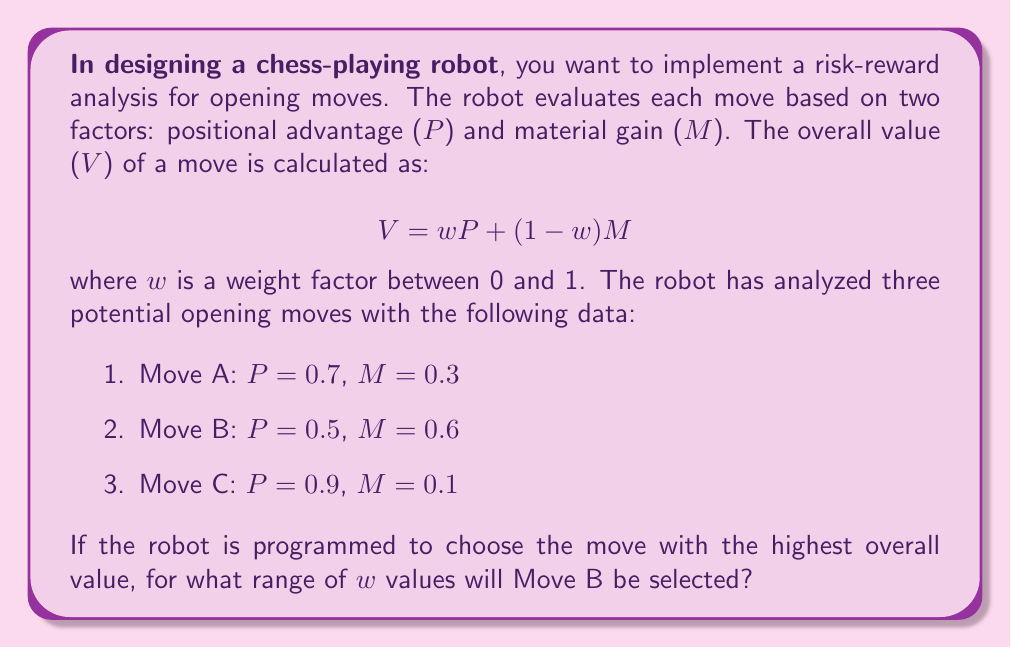Can you solve this math problem? To solve this problem, we need to follow these steps:

1. Express the value function for each move in terms of $w$.
2. Determine the conditions for Move B to have a higher value than both Move A and Move C.
3. Solve the resulting inequalities to find the range of $w$.

Step 1: Express value functions

For Move A: $V_A = 0.7w + 0.3(1-w) = 0.7w + 0.3 - 0.3w = 0.4w + 0.3$
For Move B: $V_B = 0.5w + 0.6(1-w) = 0.5w + 0.6 - 0.6w = -0.1w + 0.6$
For Move C: $V_C = 0.9w + 0.1(1-w) = 0.9w + 0.1 - 0.1w = 0.8w + 0.1$

Step 2: Determine conditions for Move B to be selected

For Move B to be selected, it must have a higher value than both Move A and Move C:

$V_B > V_A$ and $V_B > V_C$

$-0.1w + 0.6 > 0.4w + 0.3$ and $-0.1w + 0.6 > 0.8w + 0.1$

Step 3: Solve the inequalities

For $V_B > V_A$:
$-0.1w + 0.6 > 0.4w + 0.3$
$0.3 > 0.5w$
$w < 0.6$

For $V_B > V_C$:
$-0.1w + 0.6 > 0.8w + 0.1$
$0.5 > 0.9w$
$w < \frac{5}{9} \approx 0.556$

For Move B to be selected, both conditions must be satisfied. Therefore, we take the more restrictive condition, which is $w < \frac{5}{9}$.

The lower bound for $w$ is 0, as specified in the problem statement.
Answer: Move B will be selected for $0 \leq w < \frac{5}{9}$ (approximately $0 \leq w < 0.556$). 